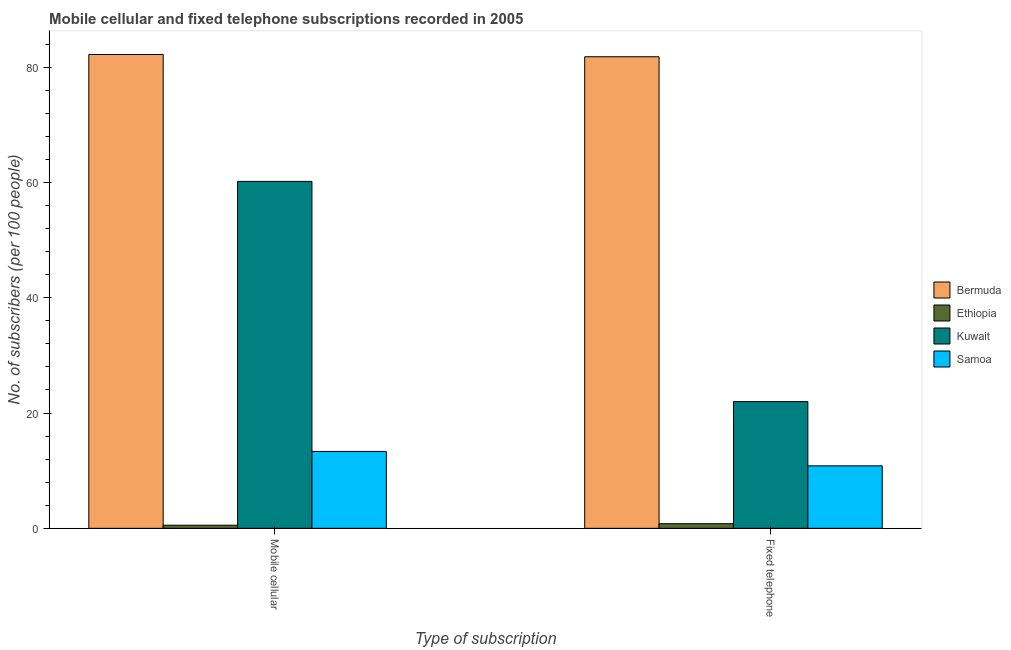How many groups of bars are there?
Keep it short and to the point. 2. Are the number of bars on each tick of the X-axis equal?
Offer a very short reply. Yes. What is the label of the 2nd group of bars from the left?
Provide a short and direct response. Fixed telephone. What is the number of mobile cellular subscribers in Bermuda?
Ensure brevity in your answer.  82.2. Across all countries, what is the maximum number of mobile cellular subscribers?
Your response must be concise. 82.2. Across all countries, what is the minimum number of mobile cellular subscribers?
Your answer should be very brief. 0.54. In which country was the number of fixed telephone subscribers maximum?
Your answer should be very brief. Bermuda. In which country was the number of mobile cellular subscribers minimum?
Ensure brevity in your answer.  Ethiopia. What is the total number of mobile cellular subscribers in the graph?
Provide a succinct answer. 156.26. What is the difference between the number of fixed telephone subscribers in Ethiopia and that in Samoa?
Give a very brief answer. -10.04. What is the difference between the number of fixed telephone subscribers in Kuwait and the number of mobile cellular subscribers in Ethiopia?
Offer a terse response. 21.44. What is the average number of mobile cellular subscribers per country?
Your answer should be compact. 39.07. What is the difference between the number of fixed telephone subscribers and number of mobile cellular subscribers in Kuwait?
Your answer should be very brief. -38.2. In how many countries, is the number of fixed telephone subscribers greater than 24 ?
Give a very brief answer. 1. What is the ratio of the number of fixed telephone subscribers in Samoa to that in Ethiopia?
Give a very brief answer. 13.52. In how many countries, is the number of fixed telephone subscribers greater than the average number of fixed telephone subscribers taken over all countries?
Provide a short and direct response. 1. What does the 2nd bar from the left in Fixed telephone represents?
Make the answer very short. Ethiopia. What does the 4th bar from the right in Mobile cellular represents?
Your response must be concise. Bermuda. How many countries are there in the graph?
Offer a terse response. 4. What is the difference between two consecutive major ticks on the Y-axis?
Ensure brevity in your answer.  20. Does the graph contain any zero values?
Make the answer very short. No. How many legend labels are there?
Give a very brief answer. 4. How are the legend labels stacked?
Keep it short and to the point. Vertical. What is the title of the graph?
Offer a terse response. Mobile cellular and fixed telephone subscriptions recorded in 2005. What is the label or title of the X-axis?
Offer a terse response. Type of subscription. What is the label or title of the Y-axis?
Give a very brief answer. No. of subscribers (per 100 people). What is the No. of subscribers (per 100 people) of Bermuda in Mobile cellular?
Make the answer very short. 82.2. What is the No. of subscribers (per 100 people) in Ethiopia in Mobile cellular?
Provide a succinct answer. 0.54. What is the No. of subscribers (per 100 people) in Kuwait in Mobile cellular?
Your answer should be compact. 60.19. What is the No. of subscribers (per 100 people) of Samoa in Mobile cellular?
Keep it short and to the point. 13.34. What is the No. of subscribers (per 100 people) of Bermuda in Fixed telephone?
Your answer should be compact. 81.81. What is the No. of subscribers (per 100 people) of Ethiopia in Fixed telephone?
Offer a very short reply. 0.8. What is the No. of subscribers (per 100 people) in Kuwait in Fixed telephone?
Ensure brevity in your answer.  21.98. What is the No. of subscribers (per 100 people) in Samoa in Fixed telephone?
Your response must be concise. 10.84. Across all Type of subscription, what is the maximum No. of subscribers (per 100 people) of Bermuda?
Your answer should be very brief. 82.2. Across all Type of subscription, what is the maximum No. of subscribers (per 100 people) in Ethiopia?
Offer a terse response. 0.8. Across all Type of subscription, what is the maximum No. of subscribers (per 100 people) in Kuwait?
Your answer should be very brief. 60.19. Across all Type of subscription, what is the maximum No. of subscribers (per 100 people) of Samoa?
Offer a very short reply. 13.34. Across all Type of subscription, what is the minimum No. of subscribers (per 100 people) in Bermuda?
Offer a terse response. 81.81. Across all Type of subscription, what is the minimum No. of subscribers (per 100 people) of Ethiopia?
Make the answer very short. 0.54. Across all Type of subscription, what is the minimum No. of subscribers (per 100 people) of Kuwait?
Keep it short and to the point. 21.98. Across all Type of subscription, what is the minimum No. of subscribers (per 100 people) of Samoa?
Your answer should be compact. 10.84. What is the total No. of subscribers (per 100 people) of Bermuda in the graph?
Offer a very short reply. 164.01. What is the total No. of subscribers (per 100 people) of Ethiopia in the graph?
Give a very brief answer. 1.34. What is the total No. of subscribers (per 100 people) of Kuwait in the graph?
Offer a terse response. 82.17. What is the total No. of subscribers (per 100 people) in Samoa in the graph?
Your answer should be compact. 24.18. What is the difference between the No. of subscribers (per 100 people) of Bermuda in Mobile cellular and that in Fixed telephone?
Ensure brevity in your answer.  0.39. What is the difference between the No. of subscribers (per 100 people) of Ethiopia in Mobile cellular and that in Fixed telephone?
Keep it short and to the point. -0.26. What is the difference between the No. of subscribers (per 100 people) of Kuwait in Mobile cellular and that in Fixed telephone?
Give a very brief answer. 38.2. What is the difference between the No. of subscribers (per 100 people) in Samoa in Mobile cellular and that in Fixed telephone?
Make the answer very short. 2.5. What is the difference between the No. of subscribers (per 100 people) in Bermuda in Mobile cellular and the No. of subscribers (per 100 people) in Ethiopia in Fixed telephone?
Ensure brevity in your answer.  81.4. What is the difference between the No. of subscribers (per 100 people) in Bermuda in Mobile cellular and the No. of subscribers (per 100 people) in Kuwait in Fixed telephone?
Provide a succinct answer. 60.22. What is the difference between the No. of subscribers (per 100 people) of Bermuda in Mobile cellular and the No. of subscribers (per 100 people) of Samoa in Fixed telephone?
Ensure brevity in your answer.  71.36. What is the difference between the No. of subscribers (per 100 people) of Ethiopia in Mobile cellular and the No. of subscribers (per 100 people) of Kuwait in Fixed telephone?
Make the answer very short. -21.44. What is the difference between the No. of subscribers (per 100 people) of Ethiopia in Mobile cellular and the No. of subscribers (per 100 people) of Samoa in Fixed telephone?
Offer a very short reply. -10.3. What is the difference between the No. of subscribers (per 100 people) in Kuwait in Mobile cellular and the No. of subscribers (per 100 people) in Samoa in Fixed telephone?
Offer a terse response. 49.35. What is the average No. of subscribers (per 100 people) in Bermuda per Type of subscription?
Give a very brief answer. 82. What is the average No. of subscribers (per 100 people) in Ethiopia per Type of subscription?
Your response must be concise. 0.67. What is the average No. of subscribers (per 100 people) in Kuwait per Type of subscription?
Keep it short and to the point. 41.09. What is the average No. of subscribers (per 100 people) in Samoa per Type of subscription?
Your answer should be compact. 12.09. What is the difference between the No. of subscribers (per 100 people) in Bermuda and No. of subscribers (per 100 people) in Ethiopia in Mobile cellular?
Make the answer very short. 81.66. What is the difference between the No. of subscribers (per 100 people) in Bermuda and No. of subscribers (per 100 people) in Kuwait in Mobile cellular?
Your response must be concise. 22.01. What is the difference between the No. of subscribers (per 100 people) of Bermuda and No. of subscribers (per 100 people) of Samoa in Mobile cellular?
Offer a terse response. 68.86. What is the difference between the No. of subscribers (per 100 people) of Ethiopia and No. of subscribers (per 100 people) of Kuwait in Mobile cellular?
Ensure brevity in your answer.  -59.65. What is the difference between the No. of subscribers (per 100 people) in Ethiopia and No. of subscribers (per 100 people) in Samoa in Mobile cellular?
Provide a short and direct response. -12.8. What is the difference between the No. of subscribers (per 100 people) of Kuwait and No. of subscribers (per 100 people) of Samoa in Mobile cellular?
Keep it short and to the point. 46.85. What is the difference between the No. of subscribers (per 100 people) of Bermuda and No. of subscribers (per 100 people) of Ethiopia in Fixed telephone?
Give a very brief answer. 81.01. What is the difference between the No. of subscribers (per 100 people) of Bermuda and No. of subscribers (per 100 people) of Kuwait in Fixed telephone?
Give a very brief answer. 59.83. What is the difference between the No. of subscribers (per 100 people) in Bermuda and No. of subscribers (per 100 people) in Samoa in Fixed telephone?
Make the answer very short. 70.97. What is the difference between the No. of subscribers (per 100 people) of Ethiopia and No. of subscribers (per 100 people) of Kuwait in Fixed telephone?
Offer a very short reply. -21.18. What is the difference between the No. of subscribers (per 100 people) of Ethiopia and No. of subscribers (per 100 people) of Samoa in Fixed telephone?
Your response must be concise. -10.04. What is the difference between the No. of subscribers (per 100 people) of Kuwait and No. of subscribers (per 100 people) of Samoa in Fixed telephone?
Your response must be concise. 11.15. What is the ratio of the No. of subscribers (per 100 people) in Ethiopia in Mobile cellular to that in Fixed telephone?
Offer a terse response. 0.67. What is the ratio of the No. of subscribers (per 100 people) in Kuwait in Mobile cellular to that in Fixed telephone?
Give a very brief answer. 2.74. What is the ratio of the No. of subscribers (per 100 people) in Samoa in Mobile cellular to that in Fixed telephone?
Keep it short and to the point. 1.23. What is the difference between the highest and the second highest No. of subscribers (per 100 people) in Bermuda?
Offer a very short reply. 0.39. What is the difference between the highest and the second highest No. of subscribers (per 100 people) in Ethiopia?
Make the answer very short. 0.26. What is the difference between the highest and the second highest No. of subscribers (per 100 people) of Kuwait?
Your answer should be very brief. 38.2. What is the difference between the highest and the second highest No. of subscribers (per 100 people) in Samoa?
Your answer should be very brief. 2.5. What is the difference between the highest and the lowest No. of subscribers (per 100 people) in Bermuda?
Your answer should be compact. 0.39. What is the difference between the highest and the lowest No. of subscribers (per 100 people) in Ethiopia?
Your response must be concise. 0.26. What is the difference between the highest and the lowest No. of subscribers (per 100 people) of Kuwait?
Provide a short and direct response. 38.2. What is the difference between the highest and the lowest No. of subscribers (per 100 people) of Samoa?
Your answer should be very brief. 2.5. 